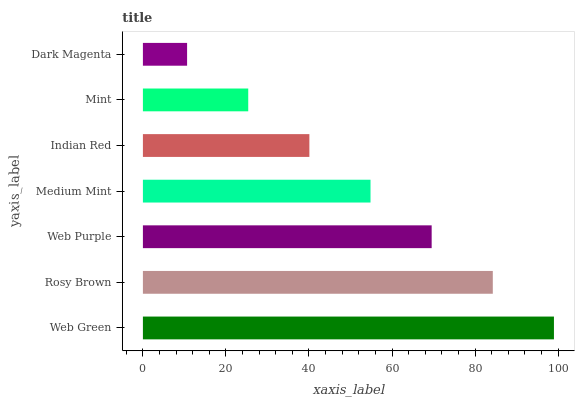Is Dark Magenta the minimum?
Answer yes or no. Yes. Is Web Green the maximum?
Answer yes or no. Yes. Is Rosy Brown the minimum?
Answer yes or no. No. Is Rosy Brown the maximum?
Answer yes or no. No. Is Web Green greater than Rosy Brown?
Answer yes or no. Yes. Is Rosy Brown less than Web Green?
Answer yes or no. Yes. Is Rosy Brown greater than Web Green?
Answer yes or no. No. Is Web Green less than Rosy Brown?
Answer yes or no. No. Is Medium Mint the high median?
Answer yes or no. Yes. Is Medium Mint the low median?
Answer yes or no. Yes. Is Mint the high median?
Answer yes or no. No. Is Mint the low median?
Answer yes or no. No. 